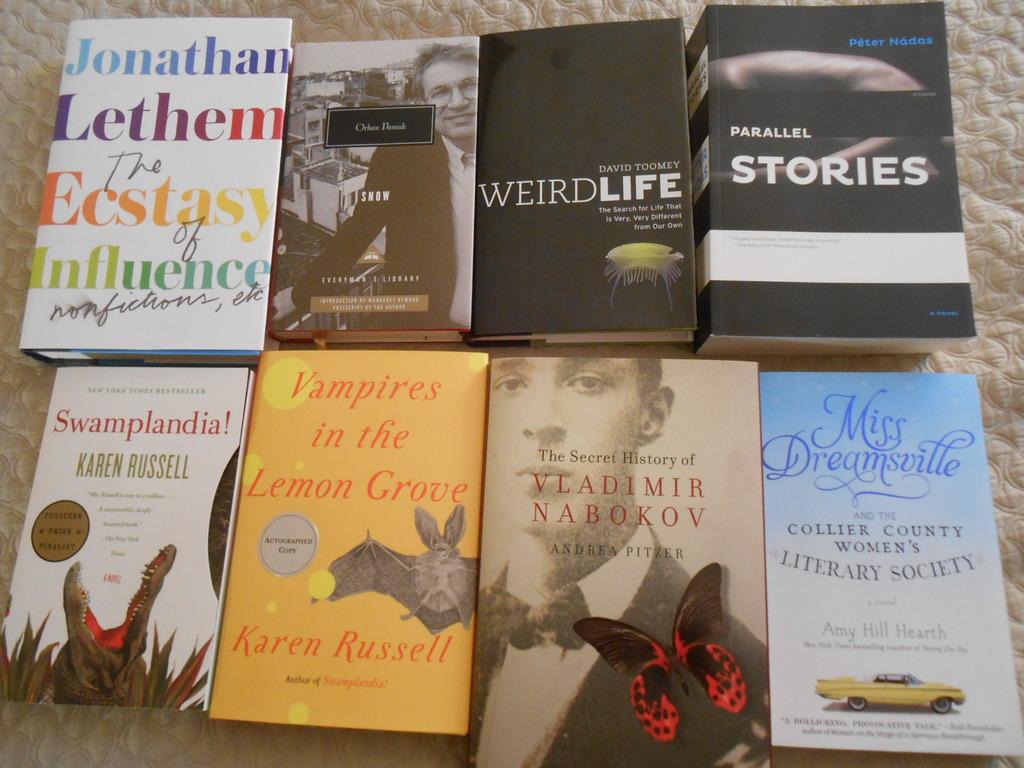The women's literary society is based in which county on this book cover?
Your answer should be very brief. Collier. What is in the lemon grove?
Provide a short and direct response. Vampires. 